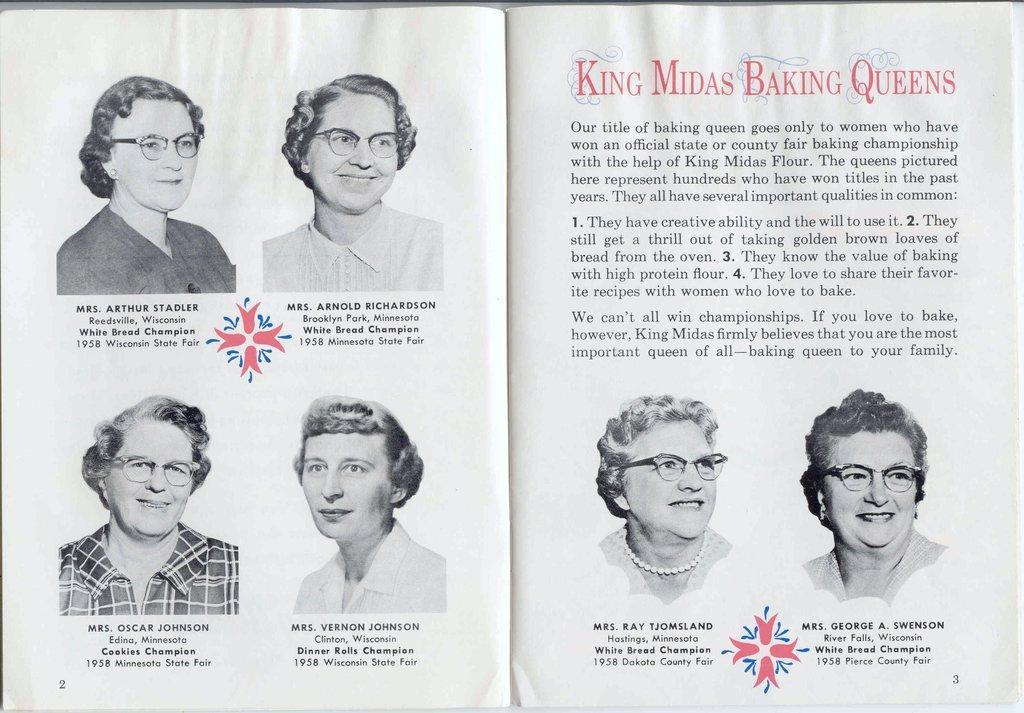Can you describe this image briefly? In this image we can see a book, there are group of persons in it, there is some matter written on it. 